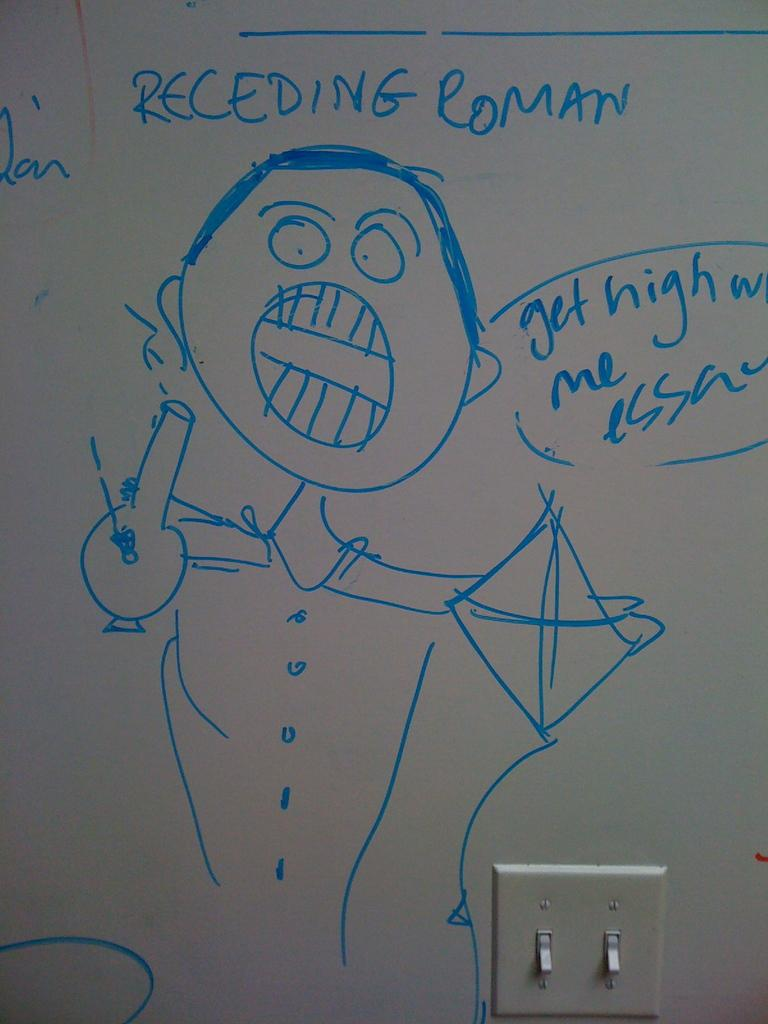<image>
Summarize the visual content of the image. A white board shows a rough handrawn person named Receding Roman, holding a bong and a kite, and saying "Get high w me essa". 